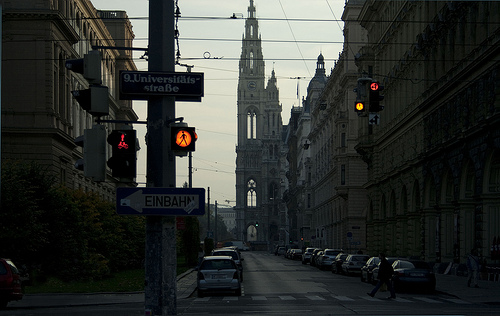Can you describe the weather conditions depicted in the image? The weather in the image appears to be clear, with no visible precipitation. The sky is overcast, and the lack of shadows on the ground suggests an absence of strong, direct sunlight. 